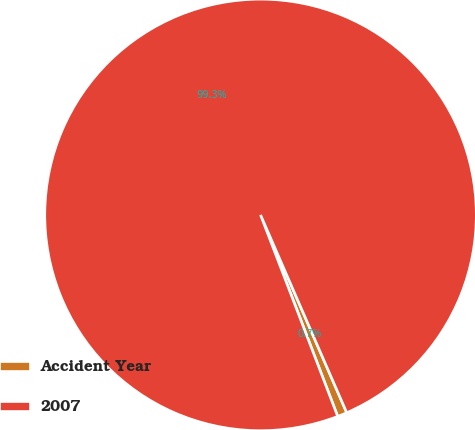Convert chart. <chart><loc_0><loc_0><loc_500><loc_500><pie_chart><fcel>Accident Year<fcel>2007<nl><fcel>0.72%<fcel>99.28%<nl></chart> 